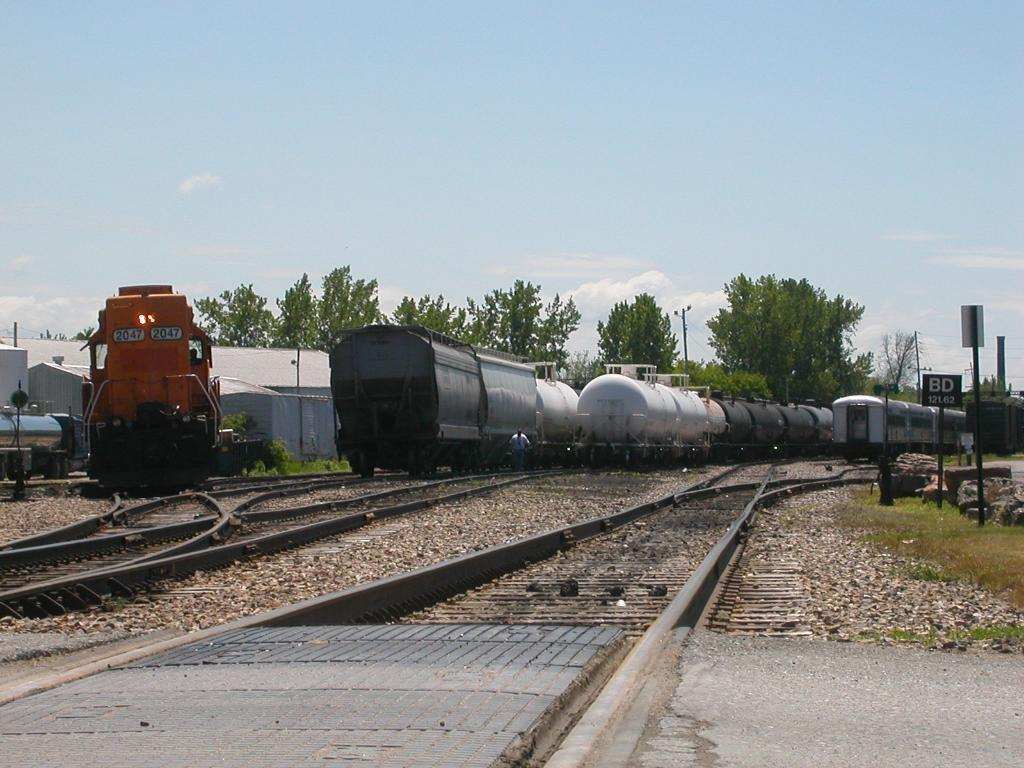What type of transportation can be seen in the image? There are trains on tracks in the image. What structures are present in the image? There are boards, poles, lights, sheds, and a vehicle in the image. What type of vegetation is visible in the image? There are plants, grass, and trees in the image. What type of ground surface is present in the image? There are stones in the image. What can be seen in the background of the image? There are trees and sky visible in the background of the image. What type of beef is being served at the team's celebration in the image? There is no team, beef, or celebration present in the image. 